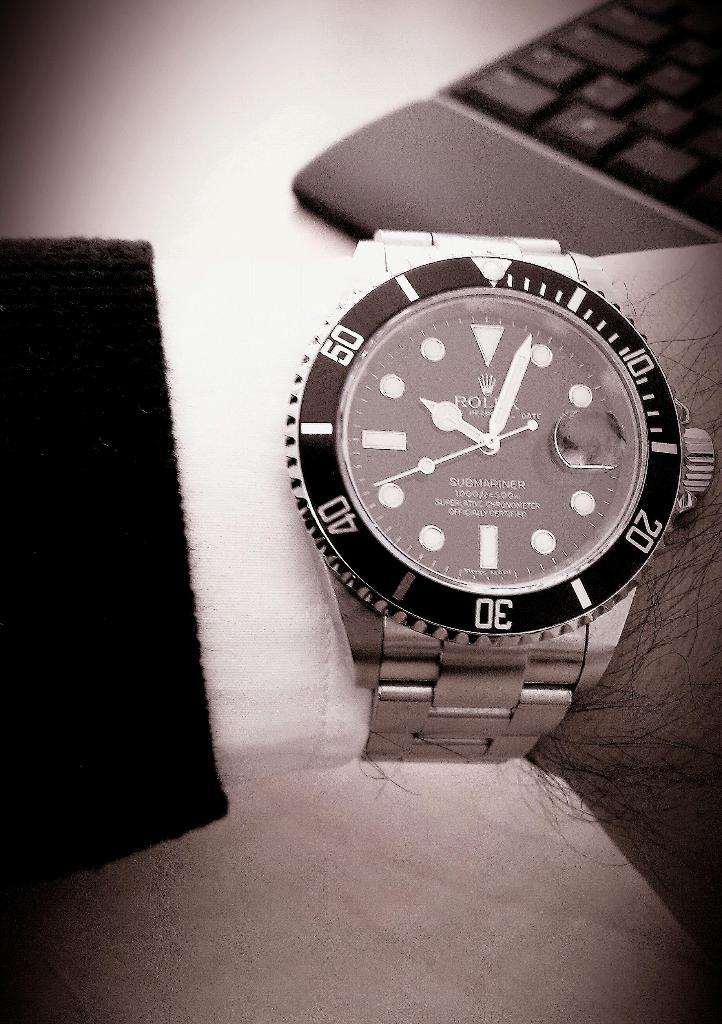<image>
Give a short and clear explanation of the subsequent image. A black and white picture of a watch with the word Rolex visible. 